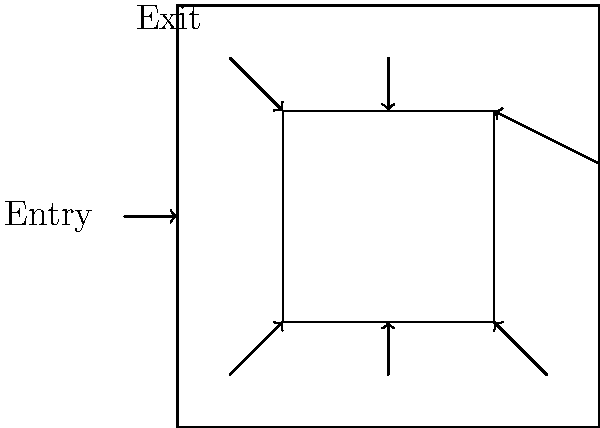Based on the directional arrows in the floor plan, which area of the exhibition space appears to be the most frequently visited by guests? To determine the most frequently visited area, we need to analyze the flow of visitors indicated by the directional arrows:

1. Visitors enter from the left side of the outer room.
2. There are three arrows pointing into the inner room from the bottom, suggesting multiple entry points.
3. Two arrows point out of the inner room: one to the right and one upwards.
4. The final arrow points towards the exit in the upper-left corner of the outer room.

By following this flow, we can see that:
- All visitors must pass through the outer room upon entry.
- Many visitors seem to enter the inner room, as indicated by multiple entry arrows.
- However, not all visitors may enter the inner room, as there's a path from entry to exit that doesn't require entering the inner space.

The inner room appears to be a focal point of the exhibition, with multiple entry points and exit routes. This suggests that it likely contains important artworks or wine-tasting stations that attract many visitors.

However, the outer room is traversed by all visitors, both upon entry and exit, and potentially by those who choose not to enter the inner room.

Given this analysis, the outer room is likely the most frequently visited area, as it serves as both the entrance and exit point for all visitors, regardless of whether they visit the inner room.
Answer: The outer room 